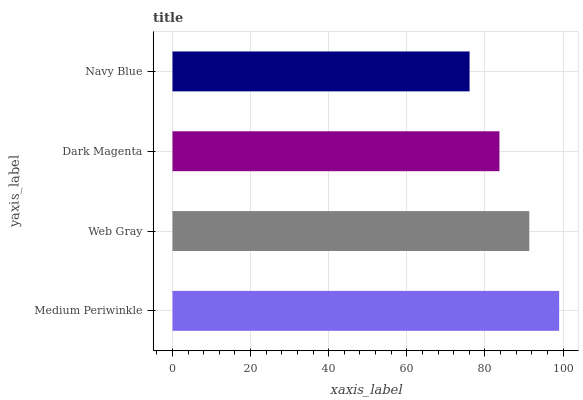Is Navy Blue the minimum?
Answer yes or no. Yes. Is Medium Periwinkle the maximum?
Answer yes or no. Yes. Is Web Gray the minimum?
Answer yes or no. No. Is Web Gray the maximum?
Answer yes or no. No. Is Medium Periwinkle greater than Web Gray?
Answer yes or no. Yes. Is Web Gray less than Medium Periwinkle?
Answer yes or no. Yes. Is Web Gray greater than Medium Periwinkle?
Answer yes or no. No. Is Medium Periwinkle less than Web Gray?
Answer yes or no. No. Is Web Gray the high median?
Answer yes or no. Yes. Is Dark Magenta the low median?
Answer yes or no. Yes. Is Dark Magenta the high median?
Answer yes or no. No. Is Web Gray the low median?
Answer yes or no. No. 